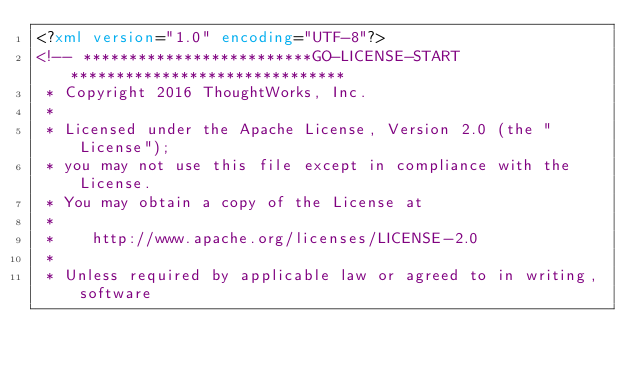Convert code to text. <code><loc_0><loc_0><loc_500><loc_500><_XML_><?xml version="1.0" encoding="UTF-8"?>
<!-- *************************GO-LICENSE-START******************************
 * Copyright 2016 ThoughtWorks, Inc.
 *
 * Licensed under the Apache License, Version 2.0 (the "License");
 * you may not use this file except in compliance with the License.
 * You may obtain a copy of the License at
 *
 *    http://www.apache.org/licenses/LICENSE-2.0
 *
 * Unless required by applicable law or agreed to in writing, software</code> 